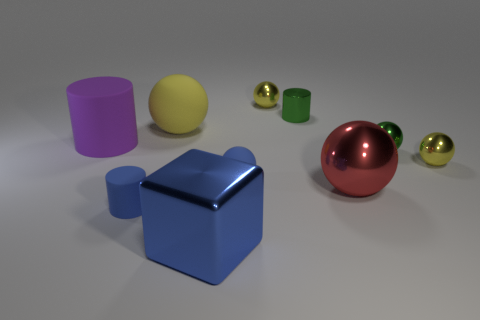Are there an equal number of purple cylinders that are on the right side of the cube and tiny gray matte cylinders?
Provide a short and direct response. Yes. There is a purple matte thing that is the same size as the blue cube; what shape is it?
Provide a succinct answer. Cylinder. What is the purple cylinder made of?
Offer a terse response. Rubber. There is a large object that is both behind the big red object and to the right of the large cylinder; what is its color?
Your answer should be compact. Yellow. Is the number of metallic balls that are behind the large yellow object the same as the number of red things on the right side of the green metallic sphere?
Give a very brief answer. No. There is a cube that is made of the same material as the green sphere; what is its color?
Keep it short and to the point. Blue. There is a large matte sphere; is it the same color as the tiny metal sphere that is to the left of the red ball?
Provide a short and direct response. Yes. There is a big metallic object left of the small ball that is behind the large purple thing; are there any green objects that are left of it?
Give a very brief answer. No. What shape is the large thing that is the same material as the purple cylinder?
Your response must be concise. Sphere. Is there any other thing that is the same shape as the blue metallic thing?
Offer a terse response. No. 